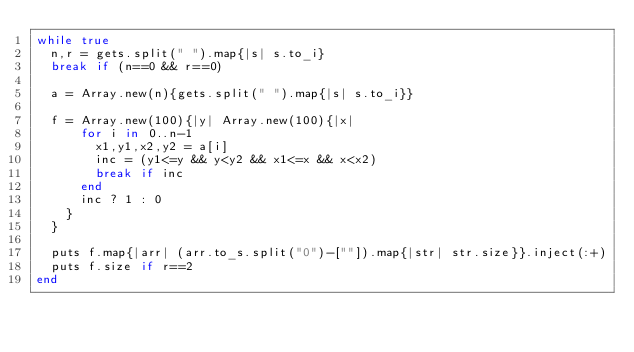Convert code to text. <code><loc_0><loc_0><loc_500><loc_500><_Ruby_>while true
  n,r = gets.split(" ").map{|s| s.to_i}
  break if (n==0 && r==0)
  
  a = Array.new(n){gets.split(" ").map{|s| s.to_i}}
  
  f = Array.new(100){|y| Array.new(100){|x|
      for i in 0..n-1
        x1,y1,x2,y2 = a[i]
        inc = (y1<=y && y<y2 && x1<=x && x<x2)
        break if inc
      end
      inc ? 1 : 0
    }
  }

  puts f.map{|arr| (arr.to_s.split("0")-[""]).map{|str| str.size}}.inject(:+)
  puts f.size if r==2
end</code> 